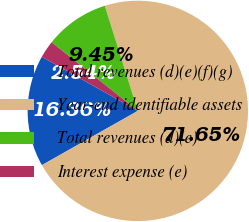Convert chart. <chart><loc_0><loc_0><loc_500><loc_500><pie_chart><fcel>Total revenues (d)(e)(f)(g)<fcel>Year-end identifiable assets<fcel>Total revenues (d)(e)<fcel>Interest expense (e)<nl><fcel>16.36%<fcel>71.66%<fcel>9.45%<fcel>2.54%<nl></chart> 